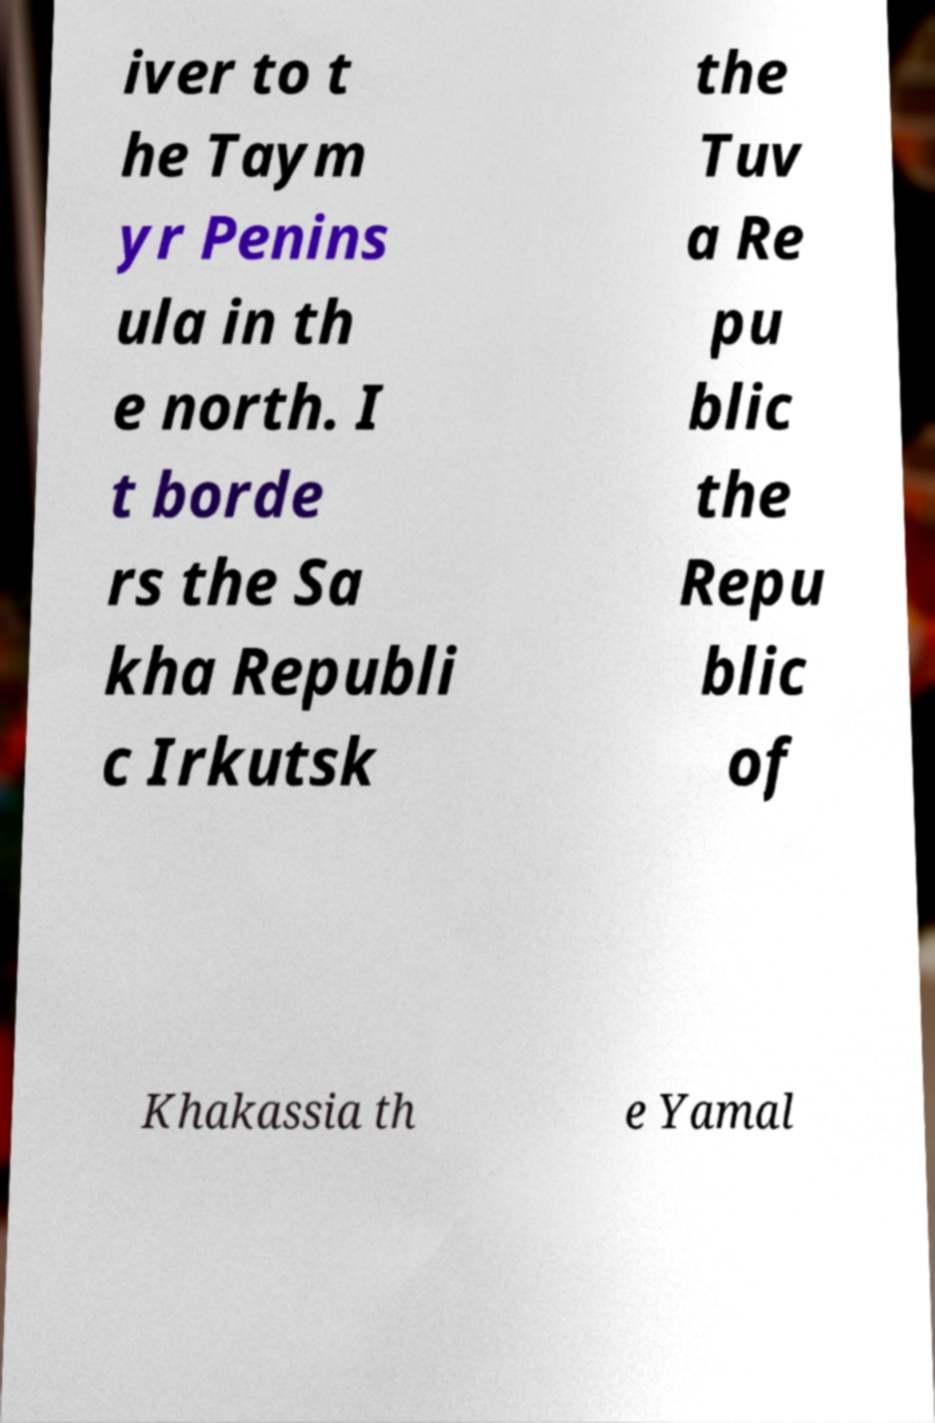For documentation purposes, I need the text within this image transcribed. Could you provide that? iver to t he Taym yr Penins ula in th e north. I t borde rs the Sa kha Republi c Irkutsk the Tuv a Re pu blic the Repu blic of Khakassia th e Yamal 